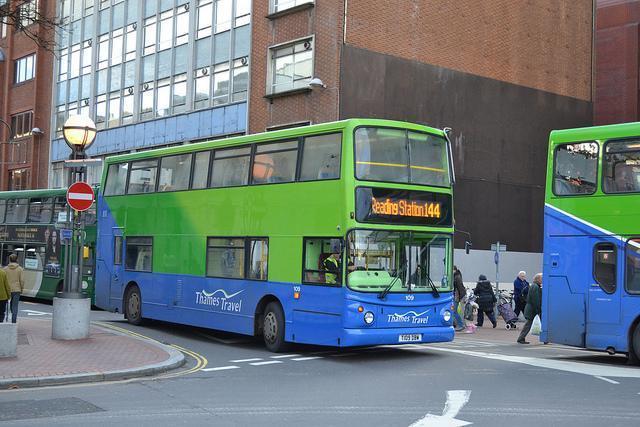How many blue and green buses are there?
Give a very brief answer. 2. How many buses are there?
Give a very brief answer. 3. 